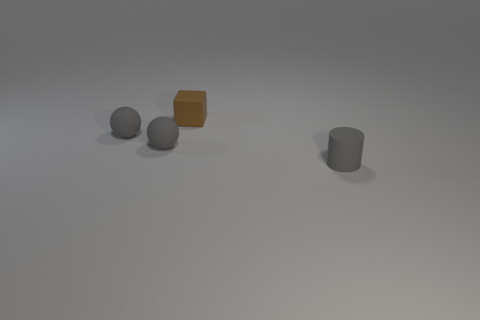Suppose I wanted to create a narrative based on this scene; could you suggest a theme or storyline involving these objects? Certainly! A theme that comes to mind is 'The Odd One Out,' where the brown cube feels distinct from the other grey objects and tries to find its place within this grouping. The story could explore themes of individuality and belonging, as the cube interacts with the spheres and cylinder, each character representing different traits and personalities. 